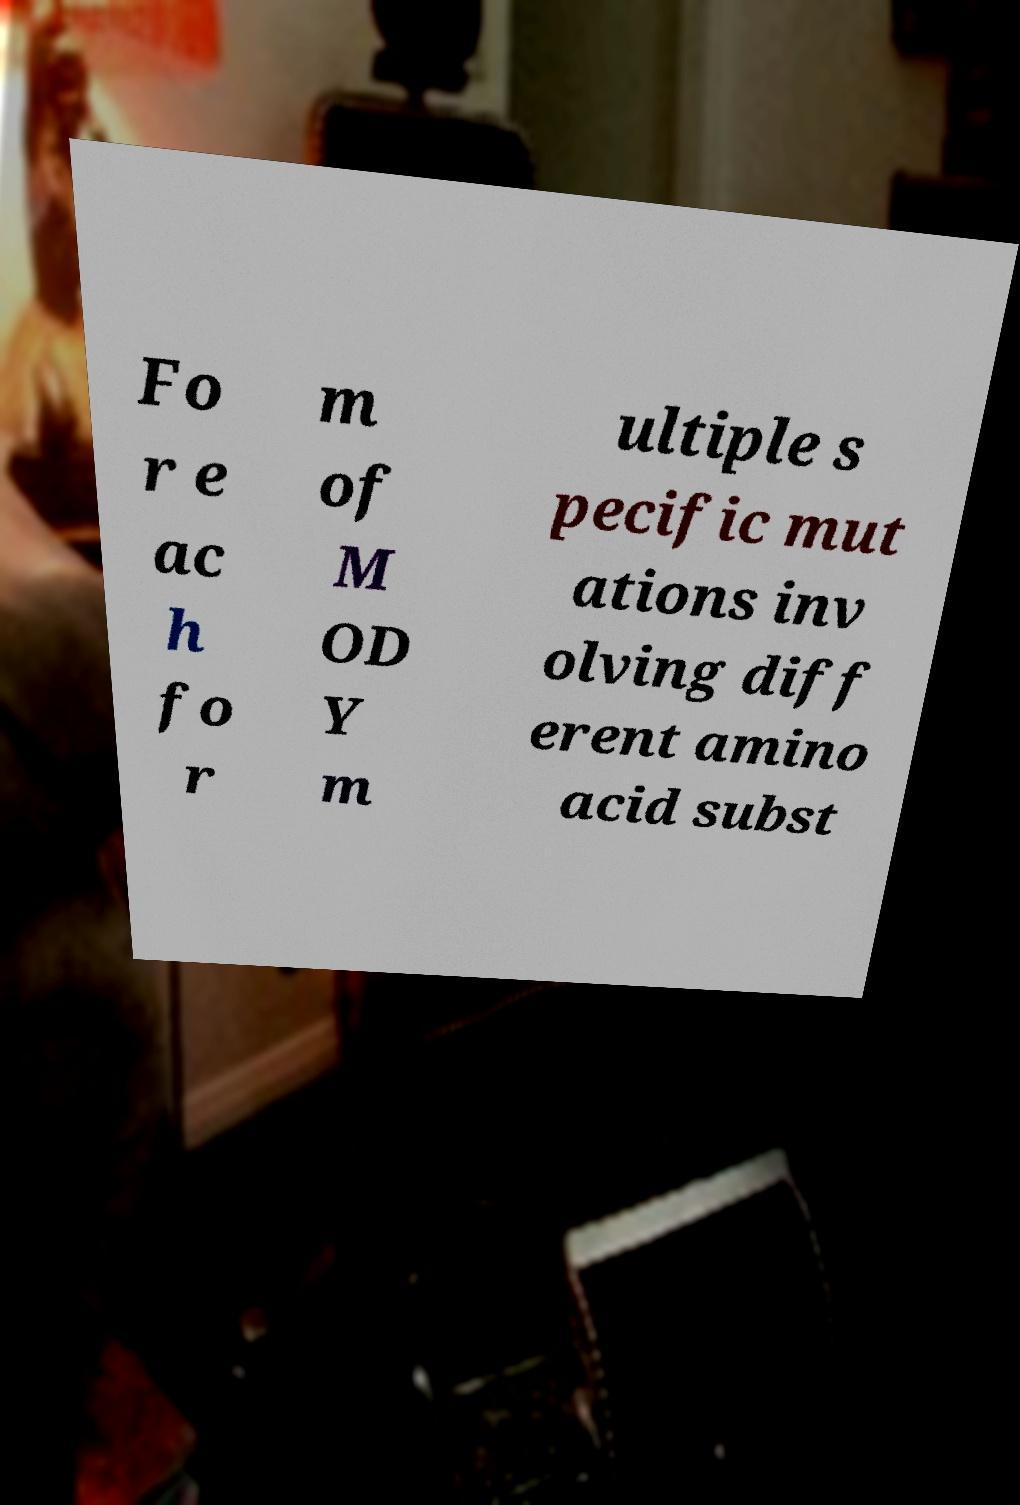For documentation purposes, I need the text within this image transcribed. Could you provide that? Fo r e ac h fo r m of M OD Y m ultiple s pecific mut ations inv olving diff erent amino acid subst 